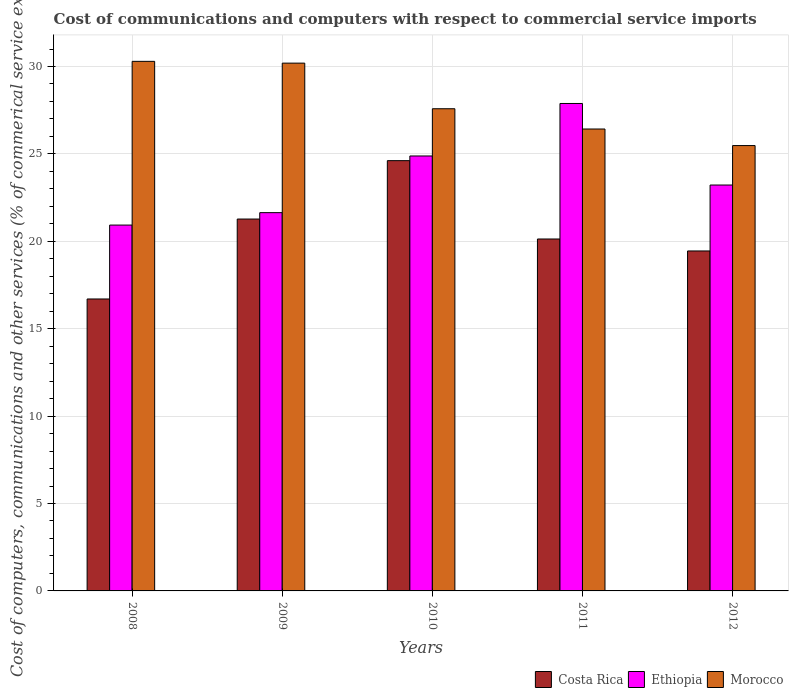Are the number of bars per tick equal to the number of legend labels?
Your answer should be very brief. Yes. What is the label of the 2nd group of bars from the left?
Make the answer very short. 2009. In how many cases, is the number of bars for a given year not equal to the number of legend labels?
Keep it short and to the point. 0. What is the cost of communications and computers in Morocco in 2012?
Your answer should be compact. 25.48. Across all years, what is the maximum cost of communications and computers in Costa Rica?
Offer a terse response. 24.61. Across all years, what is the minimum cost of communications and computers in Costa Rica?
Offer a very short reply. 16.7. In which year was the cost of communications and computers in Morocco minimum?
Offer a very short reply. 2012. What is the total cost of communications and computers in Morocco in the graph?
Your response must be concise. 139.97. What is the difference between the cost of communications and computers in Costa Rica in 2008 and that in 2009?
Your answer should be compact. -4.57. What is the difference between the cost of communications and computers in Costa Rica in 2008 and the cost of communications and computers in Ethiopia in 2010?
Keep it short and to the point. -8.18. What is the average cost of communications and computers in Costa Rica per year?
Give a very brief answer. 20.43. In the year 2009, what is the difference between the cost of communications and computers in Costa Rica and cost of communications and computers in Morocco?
Provide a succinct answer. -8.92. What is the ratio of the cost of communications and computers in Morocco in 2009 to that in 2011?
Give a very brief answer. 1.14. Is the difference between the cost of communications and computers in Costa Rica in 2011 and 2012 greater than the difference between the cost of communications and computers in Morocco in 2011 and 2012?
Your response must be concise. No. What is the difference between the highest and the second highest cost of communications and computers in Costa Rica?
Ensure brevity in your answer.  3.34. What is the difference between the highest and the lowest cost of communications and computers in Costa Rica?
Give a very brief answer. 7.91. In how many years, is the cost of communications and computers in Ethiopia greater than the average cost of communications and computers in Ethiopia taken over all years?
Provide a succinct answer. 2. Is the sum of the cost of communications and computers in Costa Rica in 2008 and 2012 greater than the maximum cost of communications and computers in Ethiopia across all years?
Keep it short and to the point. Yes. What does the 3rd bar from the left in 2009 represents?
Ensure brevity in your answer.  Morocco. What does the 1st bar from the right in 2010 represents?
Keep it short and to the point. Morocco. Is it the case that in every year, the sum of the cost of communications and computers in Costa Rica and cost of communications and computers in Ethiopia is greater than the cost of communications and computers in Morocco?
Provide a succinct answer. Yes. How many bars are there?
Your response must be concise. 15. What is the difference between two consecutive major ticks on the Y-axis?
Your response must be concise. 5. Does the graph contain any zero values?
Offer a very short reply. No. How many legend labels are there?
Keep it short and to the point. 3. What is the title of the graph?
Provide a short and direct response. Cost of communications and computers with respect to commercial service imports. What is the label or title of the X-axis?
Keep it short and to the point. Years. What is the label or title of the Y-axis?
Give a very brief answer. Cost of computers, communications and other services (% of commerical service exports). What is the Cost of computers, communications and other services (% of commerical service exports) in Costa Rica in 2008?
Ensure brevity in your answer.  16.7. What is the Cost of computers, communications and other services (% of commerical service exports) in Ethiopia in 2008?
Your answer should be compact. 20.93. What is the Cost of computers, communications and other services (% of commerical service exports) in Morocco in 2008?
Provide a succinct answer. 30.29. What is the Cost of computers, communications and other services (% of commerical service exports) in Costa Rica in 2009?
Give a very brief answer. 21.27. What is the Cost of computers, communications and other services (% of commerical service exports) in Ethiopia in 2009?
Make the answer very short. 21.64. What is the Cost of computers, communications and other services (% of commerical service exports) of Morocco in 2009?
Ensure brevity in your answer.  30.19. What is the Cost of computers, communications and other services (% of commerical service exports) in Costa Rica in 2010?
Ensure brevity in your answer.  24.61. What is the Cost of computers, communications and other services (% of commerical service exports) of Ethiopia in 2010?
Keep it short and to the point. 24.88. What is the Cost of computers, communications and other services (% of commerical service exports) in Morocco in 2010?
Offer a very short reply. 27.58. What is the Cost of computers, communications and other services (% of commerical service exports) of Costa Rica in 2011?
Offer a very short reply. 20.13. What is the Cost of computers, communications and other services (% of commerical service exports) in Ethiopia in 2011?
Your response must be concise. 27.88. What is the Cost of computers, communications and other services (% of commerical service exports) in Morocco in 2011?
Keep it short and to the point. 26.42. What is the Cost of computers, communications and other services (% of commerical service exports) of Costa Rica in 2012?
Your answer should be very brief. 19.45. What is the Cost of computers, communications and other services (% of commerical service exports) of Ethiopia in 2012?
Offer a terse response. 23.22. What is the Cost of computers, communications and other services (% of commerical service exports) in Morocco in 2012?
Provide a short and direct response. 25.48. Across all years, what is the maximum Cost of computers, communications and other services (% of commerical service exports) of Costa Rica?
Provide a short and direct response. 24.61. Across all years, what is the maximum Cost of computers, communications and other services (% of commerical service exports) of Ethiopia?
Provide a succinct answer. 27.88. Across all years, what is the maximum Cost of computers, communications and other services (% of commerical service exports) of Morocco?
Give a very brief answer. 30.29. Across all years, what is the minimum Cost of computers, communications and other services (% of commerical service exports) of Costa Rica?
Your answer should be very brief. 16.7. Across all years, what is the minimum Cost of computers, communications and other services (% of commerical service exports) in Ethiopia?
Give a very brief answer. 20.93. Across all years, what is the minimum Cost of computers, communications and other services (% of commerical service exports) of Morocco?
Offer a terse response. 25.48. What is the total Cost of computers, communications and other services (% of commerical service exports) in Costa Rica in the graph?
Offer a terse response. 102.17. What is the total Cost of computers, communications and other services (% of commerical service exports) of Ethiopia in the graph?
Ensure brevity in your answer.  118.55. What is the total Cost of computers, communications and other services (% of commerical service exports) in Morocco in the graph?
Your answer should be compact. 139.97. What is the difference between the Cost of computers, communications and other services (% of commerical service exports) of Costa Rica in 2008 and that in 2009?
Keep it short and to the point. -4.57. What is the difference between the Cost of computers, communications and other services (% of commerical service exports) of Ethiopia in 2008 and that in 2009?
Keep it short and to the point. -0.71. What is the difference between the Cost of computers, communications and other services (% of commerical service exports) in Morocco in 2008 and that in 2009?
Your answer should be compact. 0.1. What is the difference between the Cost of computers, communications and other services (% of commerical service exports) in Costa Rica in 2008 and that in 2010?
Your answer should be compact. -7.91. What is the difference between the Cost of computers, communications and other services (% of commerical service exports) of Ethiopia in 2008 and that in 2010?
Your answer should be compact. -3.95. What is the difference between the Cost of computers, communications and other services (% of commerical service exports) of Morocco in 2008 and that in 2010?
Provide a succinct answer. 2.71. What is the difference between the Cost of computers, communications and other services (% of commerical service exports) of Costa Rica in 2008 and that in 2011?
Keep it short and to the point. -3.43. What is the difference between the Cost of computers, communications and other services (% of commerical service exports) of Ethiopia in 2008 and that in 2011?
Give a very brief answer. -6.96. What is the difference between the Cost of computers, communications and other services (% of commerical service exports) in Morocco in 2008 and that in 2011?
Give a very brief answer. 3.87. What is the difference between the Cost of computers, communications and other services (% of commerical service exports) in Costa Rica in 2008 and that in 2012?
Your answer should be compact. -2.75. What is the difference between the Cost of computers, communications and other services (% of commerical service exports) in Ethiopia in 2008 and that in 2012?
Offer a terse response. -2.29. What is the difference between the Cost of computers, communications and other services (% of commerical service exports) in Morocco in 2008 and that in 2012?
Give a very brief answer. 4.82. What is the difference between the Cost of computers, communications and other services (% of commerical service exports) of Costa Rica in 2009 and that in 2010?
Make the answer very short. -3.34. What is the difference between the Cost of computers, communications and other services (% of commerical service exports) in Ethiopia in 2009 and that in 2010?
Ensure brevity in your answer.  -3.24. What is the difference between the Cost of computers, communications and other services (% of commerical service exports) of Morocco in 2009 and that in 2010?
Provide a short and direct response. 2.61. What is the difference between the Cost of computers, communications and other services (% of commerical service exports) of Costa Rica in 2009 and that in 2011?
Offer a terse response. 1.14. What is the difference between the Cost of computers, communications and other services (% of commerical service exports) of Ethiopia in 2009 and that in 2011?
Your response must be concise. -6.24. What is the difference between the Cost of computers, communications and other services (% of commerical service exports) of Morocco in 2009 and that in 2011?
Your answer should be very brief. 3.77. What is the difference between the Cost of computers, communications and other services (% of commerical service exports) in Costa Rica in 2009 and that in 2012?
Offer a terse response. 1.83. What is the difference between the Cost of computers, communications and other services (% of commerical service exports) of Ethiopia in 2009 and that in 2012?
Your response must be concise. -1.58. What is the difference between the Cost of computers, communications and other services (% of commerical service exports) in Morocco in 2009 and that in 2012?
Give a very brief answer. 4.72. What is the difference between the Cost of computers, communications and other services (% of commerical service exports) of Costa Rica in 2010 and that in 2011?
Provide a short and direct response. 4.48. What is the difference between the Cost of computers, communications and other services (% of commerical service exports) in Ethiopia in 2010 and that in 2011?
Make the answer very short. -3. What is the difference between the Cost of computers, communications and other services (% of commerical service exports) of Morocco in 2010 and that in 2011?
Your response must be concise. 1.16. What is the difference between the Cost of computers, communications and other services (% of commerical service exports) in Costa Rica in 2010 and that in 2012?
Ensure brevity in your answer.  5.17. What is the difference between the Cost of computers, communications and other services (% of commerical service exports) in Ethiopia in 2010 and that in 2012?
Give a very brief answer. 1.66. What is the difference between the Cost of computers, communications and other services (% of commerical service exports) of Morocco in 2010 and that in 2012?
Offer a terse response. 2.11. What is the difference between the Cost of computers, communications and other services (% of commerical service exports) in Costa Rica in 2011 and that in 2012?
Your response must be concise. 0.68. What is the difference between the Cost of computers, communications and other services (% of commerical service exports) in Ethiopia in 2011 and that in 2012?
Offer a terse response. 4.66. What is the difference between the Cost of computers, communications and other services (% of commerical service exports) of Morocco in 2011 and that in 2012?
Offer a terse response. 0.95. What is the difference between the Cost of computers, communications and other services (% of commerical service exports) of Costa Rica in 2008 and the Cost of computers, communications and other services (% of commerical service exports) of Ethiopia in 2009?
Your response must be concise. -4.94. What is the difference between the Cost of computers, communications and other services (% of commerical service exports) in Costa Rica in 2008 and the Cost of computers, communications and other services (% of commerical service exports) in Morocco in 2009?
Your response must be concise. -13.49. What is the difference between the Cost of computers, communications and other services (% of commerical service exports) of Ethiopia in 2008 and the Cost of computers, communications and other services (% of commerical service exports) of Morocco in 2009?
Keep it short and to the point. -9.26. What is the difference between the Cost of computers, communications and other services (% of commerical service exports) of Costa Rica in 2008 and the Cost of computers, communications and other services (% of commerical service exports) of Ethiopia in 2010?
Your response must be concise. -8.18. What is the difference between the Cost of computers, communications and other services (% of commerical service exports) of Costa Rica in 2008 and the Cost of computers, communications and other services (% of commerical service exports) of Morocco in 2010?
Your answer should be very brief. -10.88. What is the difference between the Cost of computers, communications and other services (% of commerical service exports) of Ethiopia in 2008 and the Cost of computers, communications and other services (% of commerical service exports) of Morocco in 2010?
Your response must be concise. -6.66. What is the difference between the Cost of computers, communications and other services (% of commerical service exports) in Costa Rica in 2008 and the Cost of computers, communications and other services (% of commerical service exports) in Ethiopia in 2011?
Provide a short and direct response. -11.18. What is the difference between the Cost of computers, communications and other services (% of commerical service exports) in Costa Rica in 2008 and the Cost of computers, communications and other services (% of commerical service exports) in Morocco in 2011?
Offer a very short reply. -9.72. What is the difference between the Cost of computers, communications and other services (% of commerical service exports) in Ethiopia in 2008 and the Cost of computers, communications and other services (% of commerical service exports) in Morocco in 2011?
Ensure brevity in your answer.  -5.5. What is the difference between the Cost of computers, communications and other services (% of commerical service exports) of Costa Rica in 2008 and the Cost of computers, communications and other services (% of commerical service exports) of Ethiopia in 2012?
Offer a very short reply. -6.52. What is the difference between the Cost of computers, communications and other services (% of commerical service exports) of Costa Rica in 2008 and the Cost of computers, communications and other services (% of commerical service exports) of Morocco in 2012?
Provide a short and direct response. -8.78. What is the difference between the Cost of computers, communications and other services (% of commerical service exports) in Ethiopia in 2008 and the Cost of computers, communications and other services (% of commerical service exports) in Morocco in 2012?
Your response must be concise. -4.55. What is the difference between the Cost of computers, communications and other services (% of commerical service exports) of Costa Rica in 2009 and the Cost of computers, communications and other services (% of commerical service exports) of Ethiopia in 2010?
Provide a short and direct response. -3.61. What is the difference between the Cost of computers, communications and other services (% of commerical service exports) of Costa Rica in 2009 and the Cost of computers, communications and other services (% of commerical service exports) of Morocco in 2010?
Your answer should be very brief. -6.31. What is the difference between the Cost of computers, communications and other services (% of commerical service exports) in Ethiopia in 2009 and the Cost of computers, communications and other services (% of commerical service exports) in Morocco in 2010?
Offer a terse response. -5.94. What is the difference between the Cost of computers, communications and other services (% of commerical service exports) in Costa Rica in 2009 and the Cost of computers, communications and other services (% of commerical service exports) in Ethiopia in 2011?
Your answer should be very brief. -6.61. What is the difference between the Cost of computers, communications and other services (% of commerical service exports) in Costa Rica in 2009 and the Cost of computers, communications and other services (% of commerical service exports) in Morocco in 2011?
Provide a short and direct response. -5.15. What is the difference between the Cost of computers, communications and other services (% of commerical service exports) in Ethiopia in 2009 and the Cost of computers, communications and other services (% of commerical service exports) in Morocco in 2011?
Ensure brevity in your answer.  -4.78. What is the difference between the Cost of computers, communications and other services (% of commerical service exports) in Costa Rica in 2009 and the Cost of computers, communications and other services (% of commerical service exports) in Ethiopia in 2012?
Your answer should be very brief. -1.95. What is the difference between the Cost of computers, communications and other services (% of commerical service exports) of Costa Rica in 2009 and the Cost of computers, communications and other services (% of commerical service exports) of Morocco in 2012?
Keep it short and to the point. -4.2. What is the difference between the Cost of computers, communications and other services (% of commerical service exports) of Ethiopia in 2009 and the Cost of computers, communications and other services (% of commerical service exports) of Morocco in 2012?
Ensure brevity in your answer.  -3.84. What is the difference between the Cost of computers, communications and other services (% of commerical service exports) in Costa Rica in 2010 and the Cost of computers, communications and other services (% of commerical service exports) in Ethiopia in 2011?
Ensure brevity in your answer.  -3.27. What is the difference between the Cost of computers, communications and other services (% of commerical service exports) of Costa Rica in 2010 and the Cost of computers, communications and other services (% of commerical service exports) of Morocco in 2011?
Give a very brief answer. -1.81. What is the difference between the Cost of computers, communications and other services (% of commerical service exports) of Ethiopia in 2010 and the Cost of computers, communications and other services (% of commerical service exports) of Morocco in 2011?
Offer a terse response. -1.54. What is the difference between the Cost of computers, communications and other services (% of commerical service exports) in Costa Rica in 2010 and the Cost of computers, communications and other services (% of commerical service exports) in Ethiopia in 2012?
Provide a succinct answer. 1.39. What is the difference between the Cost of computers, communications and other services (% of commerical service exports) in Costa Rica in 2010 and the Cost of computers, communications and other services (% of commerical service exports) in Morocco in 2012?
Give a very brief answer. -0.86. What is the difference between the Cost of computers, communications and other services (% of commerical service exports) in Ethiopia in 2010 and the Cost of computers, communications and other services (% of commerical service exports) in Morocco in 2012?
Give a very brief answer. -0.6. What is the difference between the Cost of computers, communications and other services (% of commerical service exports) of Costa Rica in 2011 and the Cost of computers, communications and other services (% of commerical service exports) of Ethiopia in 2012?
Keep it short and to the point. -3.09. What is the difference between the Cost of computers, communications and other services (% of commerical service exports) of Costa Rica in 2011 and the Cost of computers, communications and other services (% of commerical service exports) of Morocco in 2012?
Make the answer very short. -5.34. What is the difference between the Cost of computers, communications and other services (% of commerical service exports) of Ethiopia in 2011 and the Cost of computers, communications and other services (% of commerical service exports) of Morocco in 2012?
Make the answer very short. 2.41. What is the average Cost of computers, communications and other services (% of commerical service exports) in Costa Rica per year?
Offer a terse response. 20.43. What is the average Cost of computers, communications and other services (% of commerical service exports) in Ethiopia per year?
Your answer should be compact. 23.71. What is the average Cost of computers, communications and other services (% of commerical service exports) of Morocco per year?
Provide a short and direct response. 27.99. In the year 2008, what is the difference between the Cost of computers, communications and other services (% of commerical service exports) in Costa Rica and Cost of computers, communications and other services (% of commerical service exports) in Ethiopia?
Your response must be concise. -4.23. In the year 2008, what is the difference between the Cost of computers, communications and other services (% of commerical service exports) in Costa Rica and Cost of computers, communications and other services (% of commerical service exports) in Morocco?
Provide a short and direct response. -13.59. In the year 2008, what is the difference between the Cost of computers, communications and other services (% of commerical service exports) in Ethiopia and Cost of computers, communications and other services (% of commerical service exports) in Morocco?
Keep it short and to the point. -9.37. In the year 2009, what is the difference between the Cost of computers, communications and other services (% of commerical service exports) of Costa Rica and Cost of computers, communications and other services (% of commerical service exports) of Ethiopia?
Your answer should be very brief. -0.36. In the year 2009, what is the difference between the Cost of computers, communications and other services (% of commerical service exports) of Costa Rica and Cost of computers, communications and other services (% of commerical service exports) of Morocco?
Make the answer very short. -8.92. In the year 2009, what is the difference between the Cost of computers, communications and other services (% of commerical service exports) of Ethiopia and Cost of computers, communications and other services (% of commerical service exports) of Morocco?
Offer a very short reply. -8.55. In the year 2010, what is the difference between the Cost of computers, communications and other services (% of commerical service exports) in Costa Rica and Cost of computers, communications and other services (% of commerical service exports) in Ethiopia?
Offer a terse response. -0.27. In the year 2010, what is the difference between the Cost of computers, communications and other services (% of commerical service exports) in Costa Rica and Cost of computers, communications and other services (% of commerical service exports) in Morocco?
Ensure brevity in your answer.  -2.97. In the year 2010, what is the difference between the Cost of computers, communications and other services (% of commerical service exports) in Ethiopia and Cost of computers, communications and other services (% of commerical service exports) in Morocco?
Offer a very short reply. -2.7. In the year 2011, what is the difference between the Cost of computers, communications and other services (% of commerical service exports) of Costa Rica and Cost of computers, communications and other services (% of commerical service exports) of Ethiopia?
Give a very brief answer. -7.75. In the year 2011, what is the difference between the Cost of computers, communications and other services (% of commerical service exports) in Costa Rica and Cost of computers, communications and other services (% of commerical service exports) in Morocco?
Provide a succinct answer. -6.29. In the year 2011, what is the difference between the Cost of computers, communications and other services (% of commerical service exports) in Ethiopia and Cost of computers, communications and other services (% of commerical service exports) in Morocco?
Provide a succinct answer. 1.46. In the year 2012, what is the difference between the Cost of computers, communications and other services (% of commerical service exports) in Costa Rica and Cost of computers, communications and other services (% of commerical service exports) in Ethiopia?
Provide a short and direct response. -3.77. In the year 2012, what is the difference between the Cost of computers, communications and other services (% of commerical service exports) in Costa Rica and Cost of computers, communications and other services (% of commerical service exports) in Morocco?
Provide a succinct answer. -6.03. In the year 2012, what is the difference between the Cost of computers, communications and other services (% of commerical service exports) of Ethiopia and Cost of computers, communications and other services (% of commerical service exports) of Morocco?
Give a very brief answer. -2.26. What is the ratio of the Cost of computers, communications and other services (% of commerical service exports) of Costa Rica in 2008 to that in 2009?
Keep it short and to the point. 0.79. What is the ratio of the Cost of computers, communications and other services (% of commerical service exports) of Ethiopia in 2008 to that in 2009?
Keep it short and to the point. 0.97. What is the ratio of the Cost of computers, communications and other services (% of commerical service exports) of Morocco in 2008 to that in 2009?
Ensure brevity in your answer.  1. What is the ratio of the Cost of computers, communications and other services (% of commerical service exports) in Costa Rica in 2008 to that in 2010?
Provide a succinct answer. 0.68. What is the ratio of the Cost of computers, communications and other services (% of commerical service exports) in Ethiopia in 2008 to that in 2010?
Make the answer very short. 0.84. What is the ratio of the Cost of computers, communications and other services (% of commerical service exports) of Morocco in 2008 to that in 2010?
Provide a succinct answer. 1.1. What is the ratio of the Cost of computers, communications and other services (% of commerical service exports) of Costa Rica in 2008 to that in 2011?
Make the answer very short. 0.83. What is the ratio of the Cost of computers, communications and other services (% of commerical service exports) of Ethiopia in 2008 to that in 2011?
Give a very brief answer. 0.75. What is the ratio of the Cost of computers, communications and other services (% of commerical service exports) in Morocco in 2008 to that in 2011?
Your answer should be very brief. 1.15. What is the ratio of the Cost of computers, communications and other services (% of commerical service exports) in Costa Rica in 2008 to that in 2012?
Offer a terse response. 0.86. What is the ratio of the Cost of computers, communications and other services (% of commerical service exports) in Ethiopia in 2008 to that in 2012?
Ensure brevity in your answer.  0.9. What is the ratio of the Cost of computers, communications and other services (% of commerical service exports) in Morocco in 2008 to that in 2012?
Give a very brief answer. 1.19. What is the ratio of the Cost of computers, communications and other services (% of commerical service exports) of Costa Rica in 2009 to that in 2010?
Your answer should be compact. 0.86. What is the ratio of the Cost of computers, communications and other services (% of commerical service exports) in Ethiopia in 2009 to that in 2010?
Your answer should be compact. 0.87. What is the ratio of the Cost of computers, communications and other services (% of commerical service exports) of Morocco in 2009 to that in 2010?
Provide a short and direct response. 1.09. What is the ratio of the Cost of computers, communications and other services (% of commerical service exports) of Costa Rica in 2009 to that in 2011?
Give a very brief answer. 1.06. What is the ratio of the Cost of computers, communications and other services (% of commerical service exports) in Ethiopia in 2009 to that in 2011?
Offer a terse response. 0.78. What is the ratio of the Cost of computers, communications and other services (% of commerical service exports) in Morocco in 2009 to that in 2011?
Offer a terse response. 1.14. What is the ratio of the Cost of computers, communications and other services (% of commerical service exports) in Costa Rica in 2009 to that in 2012?
Your answer should be very brief. 1.09. What is the ratio of the Cost of computers, communications and other services (% of commerical service exports) of Ethiopia in 2009 to that in 2012?
Offer a terse response. 0.93. What is the ratio of the Cost of computers, communications and other services (% of commerical service exports) in Morocco in 2009 to that in 2012?
Provide a short and direct response. 1.19. What is the ratio of the Cost of computers, communications and other services (% of commerical service exports) of Costa Rica in 2010 to that in 2011?
Ensure brevity in your answer.  1.22. What is the ratio of the Cost of computers, communications and other services (% of commerical service exports) of Ethiopia in 2010 to that in 2011?
Ensure brevity in your answer.  0.89. What is the ratio of the Cost of computers, communications and other services (% of commerical service exports) of Morocco in 2010 to that in 2011?
Provide a succinct answer. 1.04. What is the ratio of the Cost of computers, communications and other services (% of commerical service exports) of Costa Rica in 2010 to that in 2012?
Provide a succinct answer. 1.27. What is the ratio of the Cost of computers, communications and other services (% of commerical service exports) of Ethiopia in 2010 to that in 2012?
Your answer should be compact. 1.07. What is the ratio of the Cost of computers, communications and other services (% of commerical service exports) of Morocco in 2010 to that in 2012?
Offer a terse response. 1.08. What is the ratio of the Cost of computers, communications and other services (% of commerical service exports) in Costa Rica in 2011 to that in 2012?
Ensure brevity in your answer.  1.04. What is the ratio of the Cost of computers, communications and other services (% of commerical service exports) in Ethiopia in 2011 to that in 2012?
Make the answer very short. 1.2. What is the ratio of the Cost of computers, communications and other services (% of commerical service exports) of Morocco in 2011 to that in 2012?
Keep it short and to the point. 1.04. What is the difference between the highest and the second highest Cost of computers, communications and other services (% of commerical service exports) in Costa Rica?
Provide a short and direct response. 3.34. What is the difference between the highest and the second highest Cost of computers, communications and other services (% of commerical service exports) of Ethiopia?
Make the answer very short. 3. What is the difference between the highest and the second highest Cost of computers, communications and other services (% of commerical service exports) in Morocco?
Ensure brevity in your answer.  0.1. What is the difference between the highest and the lowest Cost of computers, communications and other services (% of commerical service exports) in Costa Rica?
Your response must be concise. 7.91. What is the difference between the highest and the lowest Cost of computers, communications and other services (% of commerical service exports) in Ethiopia?
Offer a very short reply. 6.96. What is the difference between the highest and the lowest Cost of computers, communications and other services (% of commerical service exports) in Morocco?
Your answer should be compact. 4.82. 